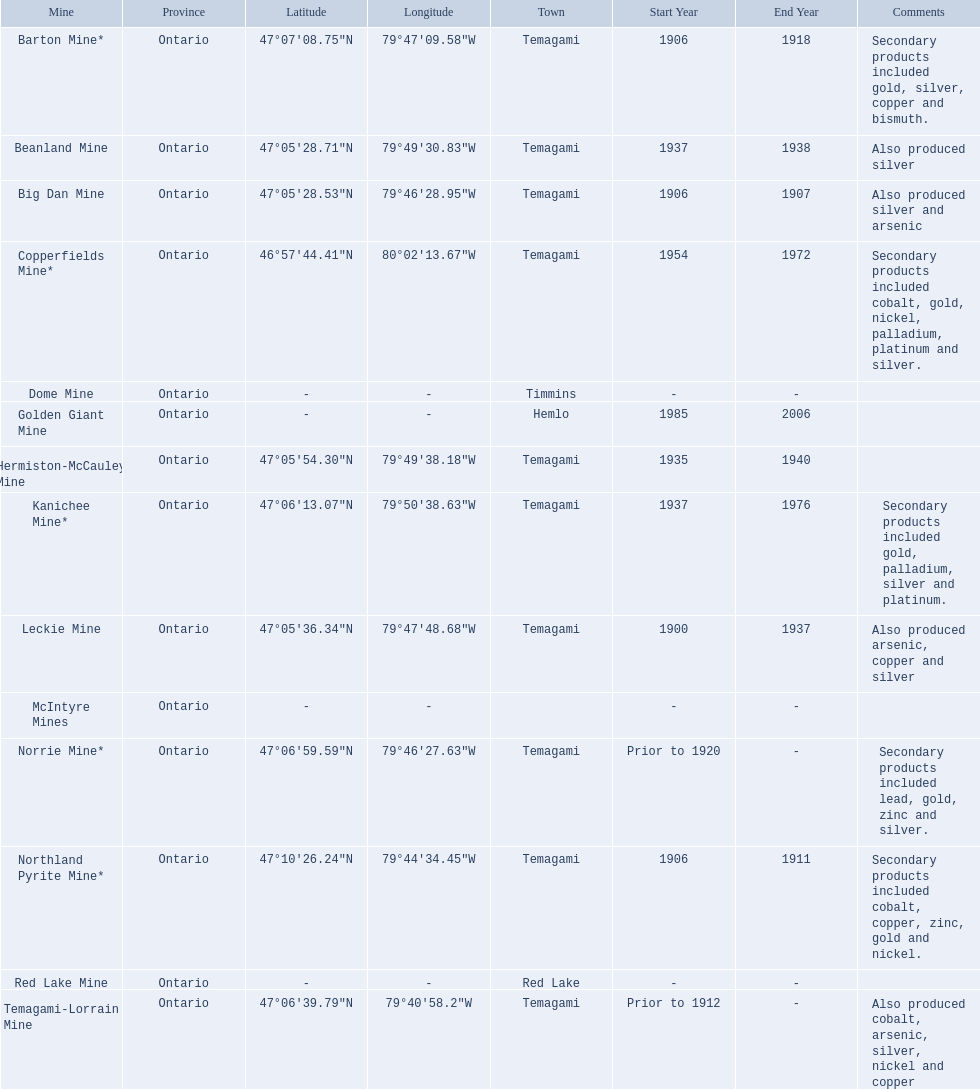What are all the mines with dates listed? Barton Mine*, Beanland Mine, Big Dan Mine, Copperfields Mine*, Golden Giant Mine, Hermiston-McCauley Mine, Kanichee Mine*, Leckie Mine, Norrie Mine*, Northland Pyrite Mine*, Temagami-Lorrain Mine. Which of those dates include the year that the mine was closed? 1906-1918, 1937-1938, 1906-1907, 1954-1972, 1985-2006, 1935-1940, 1937-1948, 1948-1949, 1973-1976, ~1900-1909, 1933-1937, 1906-1911. Could you help me parse every detail presented in this table? {'header': ['Mine', 'Province', 'Latitude', 'Longitude', 'Town', 'Start Year', 'End Year', 'Comments'], 'rows': [['Barton Mine*', 'Ontario', '47°07′08.75″N', '79°47′09.58″W', 'Temagami', '1906', '1918', 'Secondary products included gold, silver, copper and bismuth.'], ['Beanland Mine', 'Ontario', '47°05′28.71″N', '79°49′30.83″W', 'Temagami', '1937', '1938', 'Also produced silver'], ['Big Dan Mine', 'Ontario', '47°05′28.53″N', '79°46′28.95″W', 'Temagami', '1906', '1907', 'Also produced silver and arsenic'], ['Copperfields Mine*', 'Ontario', '46°57′44.41″N', '80°02′13.67″W', 'Temagami', '1954', '1972', 'Secondary products included cobalt, gold, nickel, palladium, platinum and silver.'], ['Dome Mine', 'Ontario', '-', '-', 'Timmins', '-', '-', ''], ['Golden Giant Mine', 'Ontario', '-', '-', 'Hemlo', '1985', '2006', ''], ['Hermiston-McCauley Mine', 'Ontario', '47°05′54.30″N', '79°49′38.18″W', 'Temagami', '1935', '1940', ''], ['Kanichee Mine*', 'Ontario', '47°06′13.07″N', '79°50′38.63″W', 'Temagami', '1937', '1976', 'Secondary products included gold, palladium, silver and platinum.'], ['Leckie Mine', 'Ontario', '47°05′36.34″N', '79°47′48.68″W', 'Temagami', '1900', '1937', 'Also produced arsenic, copper and silver'], ['McIntyre Mines', 'Ontario', '-', '-', '', '-', '-', ''], ['Norrie Mine*', 'Ontario', '47°06′59.59″N', '79°46′27.63″W', 'Temagami', 'Prior to 1920', '-', 'Secondary products included lead, gold, zinc and silver.'], ['Northland Pyrite Mine*', 'Ontario', '47°10′26.24″N', '79°44′34.45″W', 'Temagami', '1906', '1911', 'Secondary products included cobalt, copper, zinc, gold and nickel.'], ['Red Lake Mine', 'Ontario', '-', '-', 'Red Lake', '-', '-', ''], ['Temagami-Lorrain Mine', 'Ontario', '47°06′39.79″N', '79°40′58.2″W', 'Temagami', 'Prior to 1912', '-', 'Also produced cobalt, arsenic, silver, nickel and copper']]} Which of those mines were opened the longest? Golden Giant Mine. What dates was the golden giant mine open? 1985-2006. What dates was the beanland mine open? 1937-1938. Of those mines, which was open longer? Golden Giant Mine. 